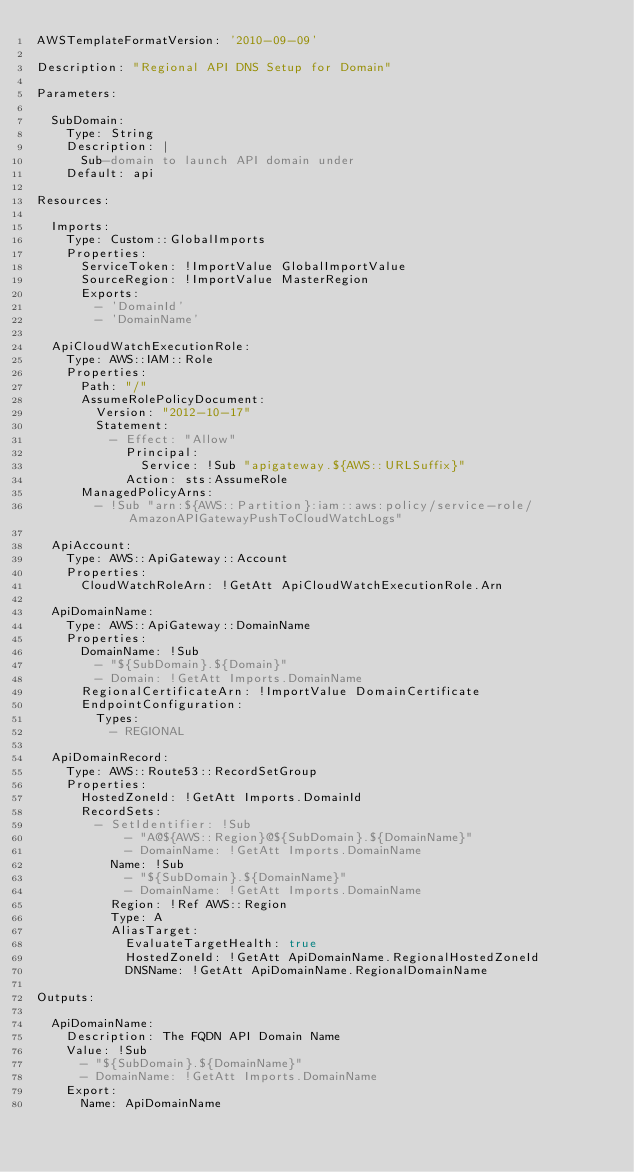<code> <loc_0><loc_0><loc_500><loc_500><_YAML_>AWSTemplateFormatVersion: '2010-09-09'

Description: "Regional API DNS Setup for Domain"

Parameters:

  SubDomain:
    Type: String
    Description: |
      Sub-domain to launch API domain under
    Default: api

Resources:

  Imports:
    Type: Custom::GlobalImports
    Properties:
      ServiceToken: !ImportValue GlobalImportValue
      SourceRegion: !ImportValue MasterRegion
      Exports:
        - 'DomainId'
        - 'DomainName'

  ApiCloudWatchExecutionRole:
    Type: AWS::IAM::Role
    Properties:
      Path: "/"
      AssumeRolePolicyDocument:
        Version: "2012-10-17"
        Statement:
          - Effect: "Allow"
            Principal:
              Service: !Sub "apigateway.${AWS::URLSuffix}"
            Action: sts:AssumeRole
      ManagedPolicyArns:
        - !Sub "arn:${AWS::Partition}:iam::aws:policy/service-role/AmazonAPIGatewayPushToCloudWatchLogs"

  ApiAccount:
    Type: AWS::ApiGateway::Account
    Properties:
      CloudWatchRoleArn: !GetAtt ApiCloudWatchExecutionRole.Arn

  ApiDomainName:
    Type: AWS::ApiGateway::DomainName
    Properties:
      DomainName: !Sub
        - "${SubDomain}.${Domain}"
        - Domain: !GetAtt Imports.DomainName
      RegionalCertificateArn: !ImportValue DomainCertificate
      EndpointConfiguration:
        Types:
          - REGIONAL

  ApiDomainRecord:
    Type: AWS::Route53::RecordSetGroup
    Properties:
      HostedZoneId: !GetAtt Imports.DomainId
      RecordSets:
        - SetIdentifier: !Sub
            - "A@${AWS::Region}@${SubDomain}.${DomainName}"
            - DomainName: !GetAtt Imports.DomainName
          Name: !Sub
            - "${SubDomain}.${DomainName}"
            - DomainName: !GetAtt Imports.DomainName
          Region: !Ref AWS::Region
          Type: A
          AliasTarget:
            EvaluateTargetHealth: true
            HostedZoneId: !GetAtt ApiDomainName.RegionalHostedZoneId
            DNSName: !GetAtt ApiDomainName.RegionalDomainName

Outputs:

  ApiDomainName:
    Description: The FQDN API Domain Name
    Value: !Sub
      - "${SubDomain}.${DomainName}"
      - DomainName: !GetAtt Imports.DomainName
    Export:
      Name: ApiDomainName</code> 